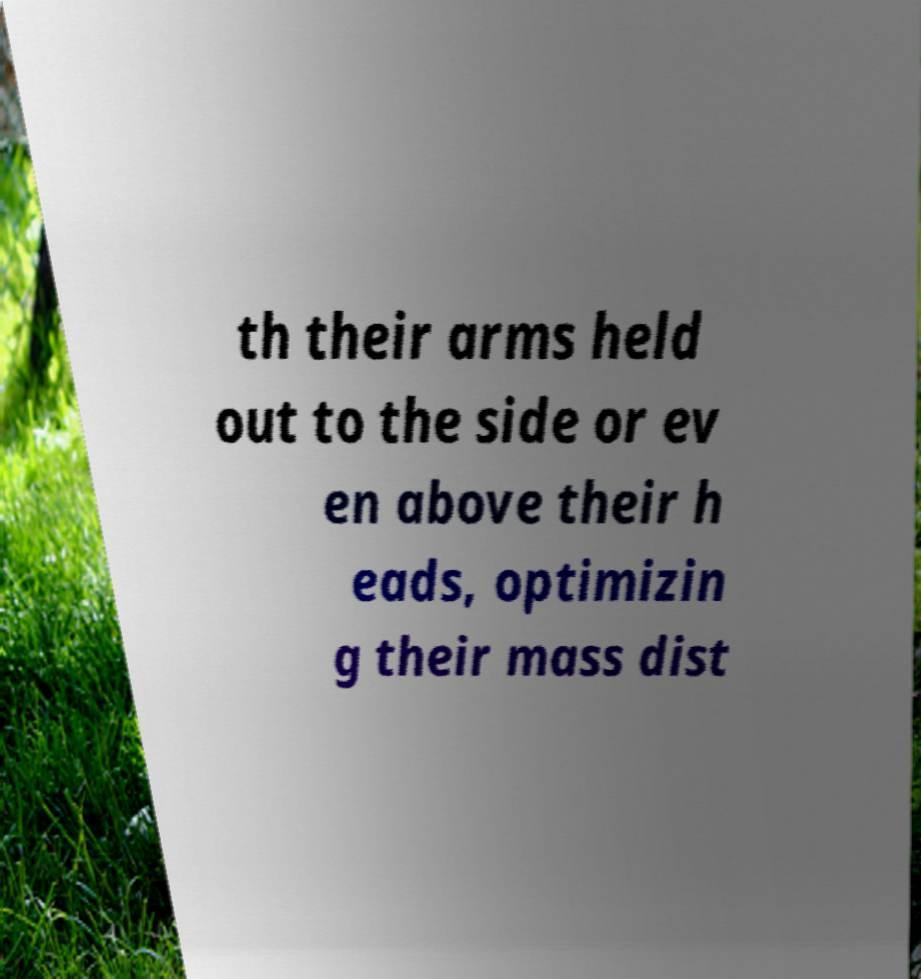Please read and relay the text visible in this image. What does it say? th their arms held out to the side or ev en above their h eads, optimizin g their mass dist 